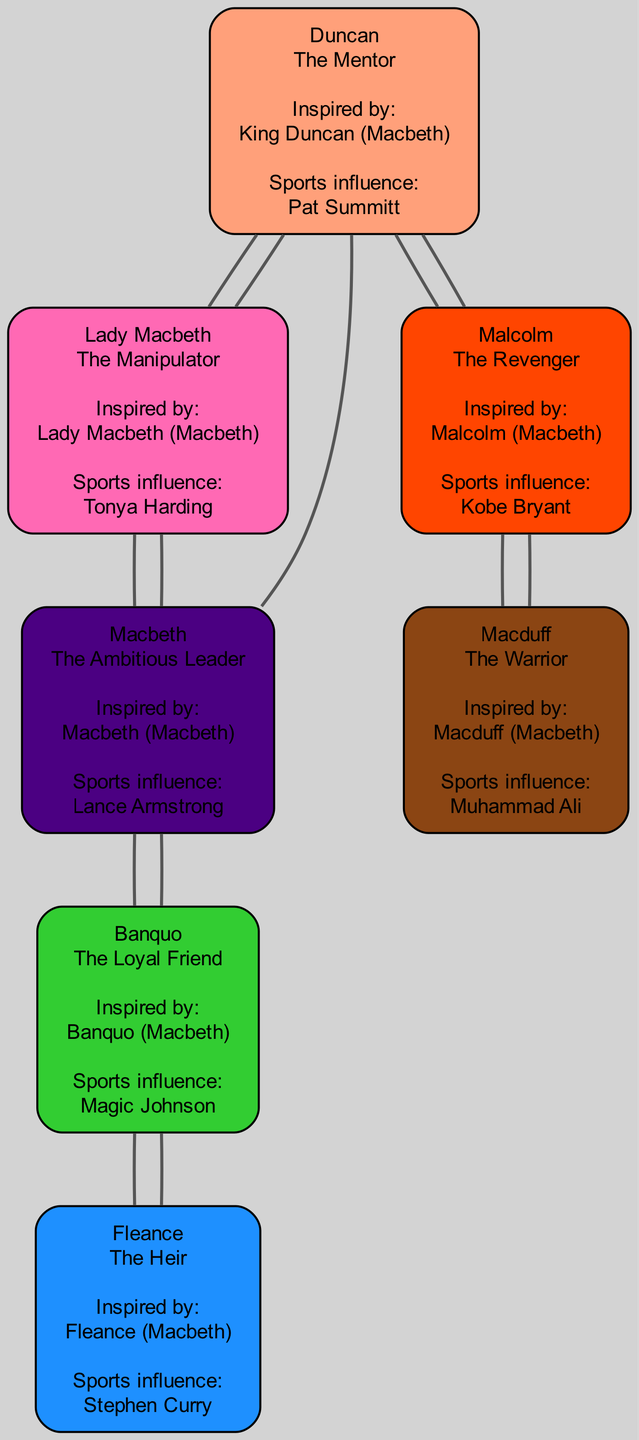What archetype does Lady Macbeth represent? The diagram shows that Lady Macbeth is labeled with the archetype "The Manipulator." This is found directly beneath her name in the node.
Answer: The Manipulator How many connections does Duncan have? By examining the connections listed under Duncan's node, we see that he has connections to Malcolm and Lady Macbeth. Therefore, there are two lines leading from his node.
Answer: 2 Which character is influenced by Kobe Bryant? The node for Malcolm states that his sports figure influence is Kobe Bryant, which is clearly mentioned in the details of his node.
Answer: Malcolm What are the names of the characters that Macbeth is connected to? The connections listed under Macbeth indicate he is connected to Lady Macbeth, Banquo, and Duncan. Thus, these three characters are linked to him.
Answer: Lady Macbeth, Banquo, Duncan Who has the archetype "The Heir"? Fleance is identified in the diagram as "The Heir" through the information directly in his node, which specifies both his name and archetype.
Answer: Fleance Which character represents the archetype of "The Warrior"? Macduff's node states that he represents "The Warrior," making it clear that this archetype is associated with him.
Answer: The Warrior How many total characters are represented in the diagram? By counting all nodes for the characters (Duncan, Lady Macbeth, Macbeth, Banquo, Fleance, Malcolm, and Macduff), we find there are seven distinct characters.
Answer: 7 What is the inspiration for Macbeth's character? The diagram clearly states that Macbeth is inspired by the character "Macbeth" from the play "Macbeth," as noted in his node details.
Answer: Macbeth (Macbeth) Which character is associated with Magic Johnson? The node for Banquo indicates that his sports figure influence is Magic Johnson, which identifies him as the character associated with this figure.
Answer: Banquo 